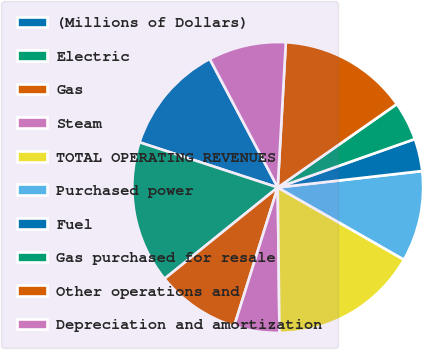<chart> <loc_0><loc_0><loc_500><loc_500><pie_chart><fcel>(Millions of Dollars)<fcel>Electric<fcel>Gas<fcel>Steam<fcel>TOTAL OPERATING REVENUES<fcel>Purchased power<fcel>Fuel<fcel>Gas purchased for resale<fcel>Other operations and<fcel>Depreciation and amortization<nl><fcel>12.23%<fcel>15.83%<fcel>9.35%<fcel>5.04%<fcel>16.54%<fcel>10.07%<fcel>3.6%<fcel>4.32%<fcel>14.39%<fcel>8.63%<nl></chart> 